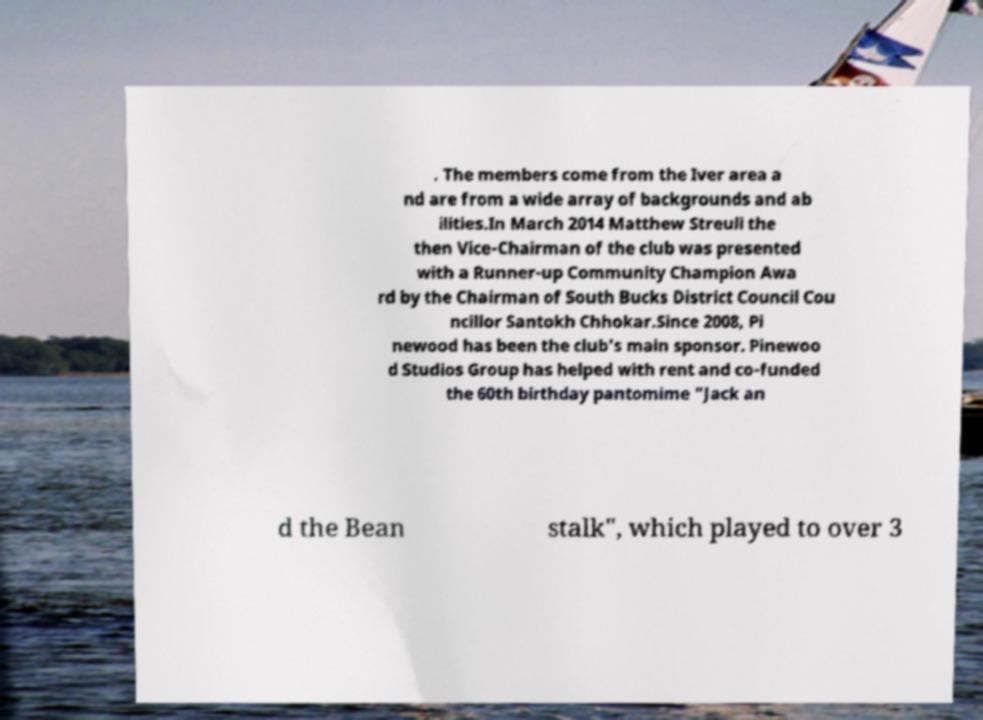I need the written content from this picture converted into text. Can you do that? . The members come from the Iver area a nd are from a wide array of backgrounds and ab ilities.In March 2014 Matthew Streuli the then Vice-Chairman of the club was presented with a Runner-up Community Champion Awa rd by the Chairman of South Bucks District Council Cou ncillor Santokh Chhokar.Since 2008, Pi newood has been the club's main sponsor. Pinewoo d Studios Group has helped with rent and co-funded the 60th birthday pantomime "Jack an d the Bean stalk", which played to over 3 